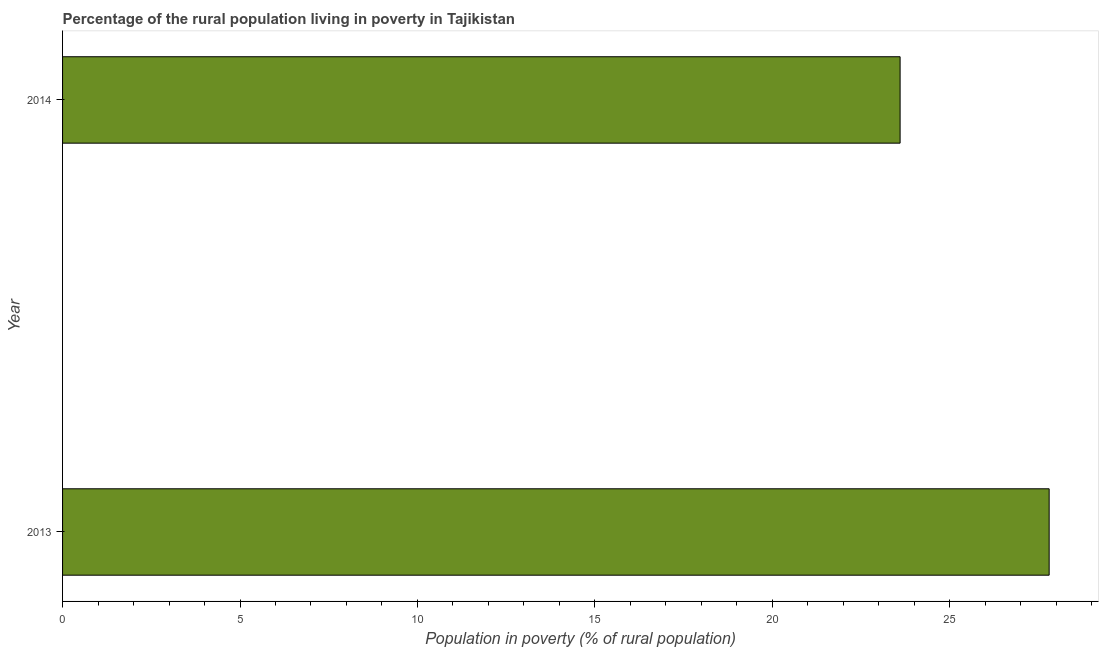Does the graph contain any zero values?
Make the answer very short. No. Does the graph contain grids?
Keep it short and to the point. No. What is the title of the graph?
Offer a very short reply. Percentage of the rural population living in poverty in Tajikistan. What is the label or title of the X-axis?
Offer a very short reply. Population in poverty (% of rural population). What is the label or title of the Y-axis?
Give a very brief answer. Year. What is the percentage of rural population living below poverty line in 2014?
Give a very brief answer. 23.6. Across all years, what is the maximum percentage of rural population living below poverty line?
Your answer should be very brief. 27.8. Across all years, what is the minimum percentage of rural population living below poverty line?
Ensure brevity in your answer.  23.6. In which year was the percentage of rural population living below poverty line maximum?
Keep it short and to the point. 2013. In which year was the percentage of rural population living below poverty line minimum?
Your answer should be very brief. 2014. What is the sum of the percentage of rural population living below poverty line?
Keep it short and to the point. 51.4. What is the average percentage of rural population living below poverty line per year?
Provide a short and direct response. 25.7. What is the median percentage of rural population living below poverty line?
Provide a short and direct response. 25.7. In how many years, is the percentage of rural population living below poverty line greater than 1 %?
Provide a succinct answer. 2. What is the ratio of the percentage of rural population living below poverty line in 2013 to that in 2014?
Provide a short and direct response. 1.18. Are all the bars in the graph horizontal?
Your answer should be very brief. Yes. How many years are there in the graph?
Your answer should be very brief. 2. What is the difference between two consecutive major ticks on the X-axis?
Offer a very short reply. 5. What is the Population in poverty (% of rural population) of 2013?
Keep it short and to the point. 27.8. What is the Population in poverty (% of rural population) in 2014?
Provide a succinct answer. 23.6. What is the difference between the Population in poverty (% of rural population) in 2013 and 2014?
Provide a short and direct response. 4.2. What is the ratio of the Population in poverty (% of rural population) in 2013 to that in 2014?
Keep it short and to the point. 1.18. 